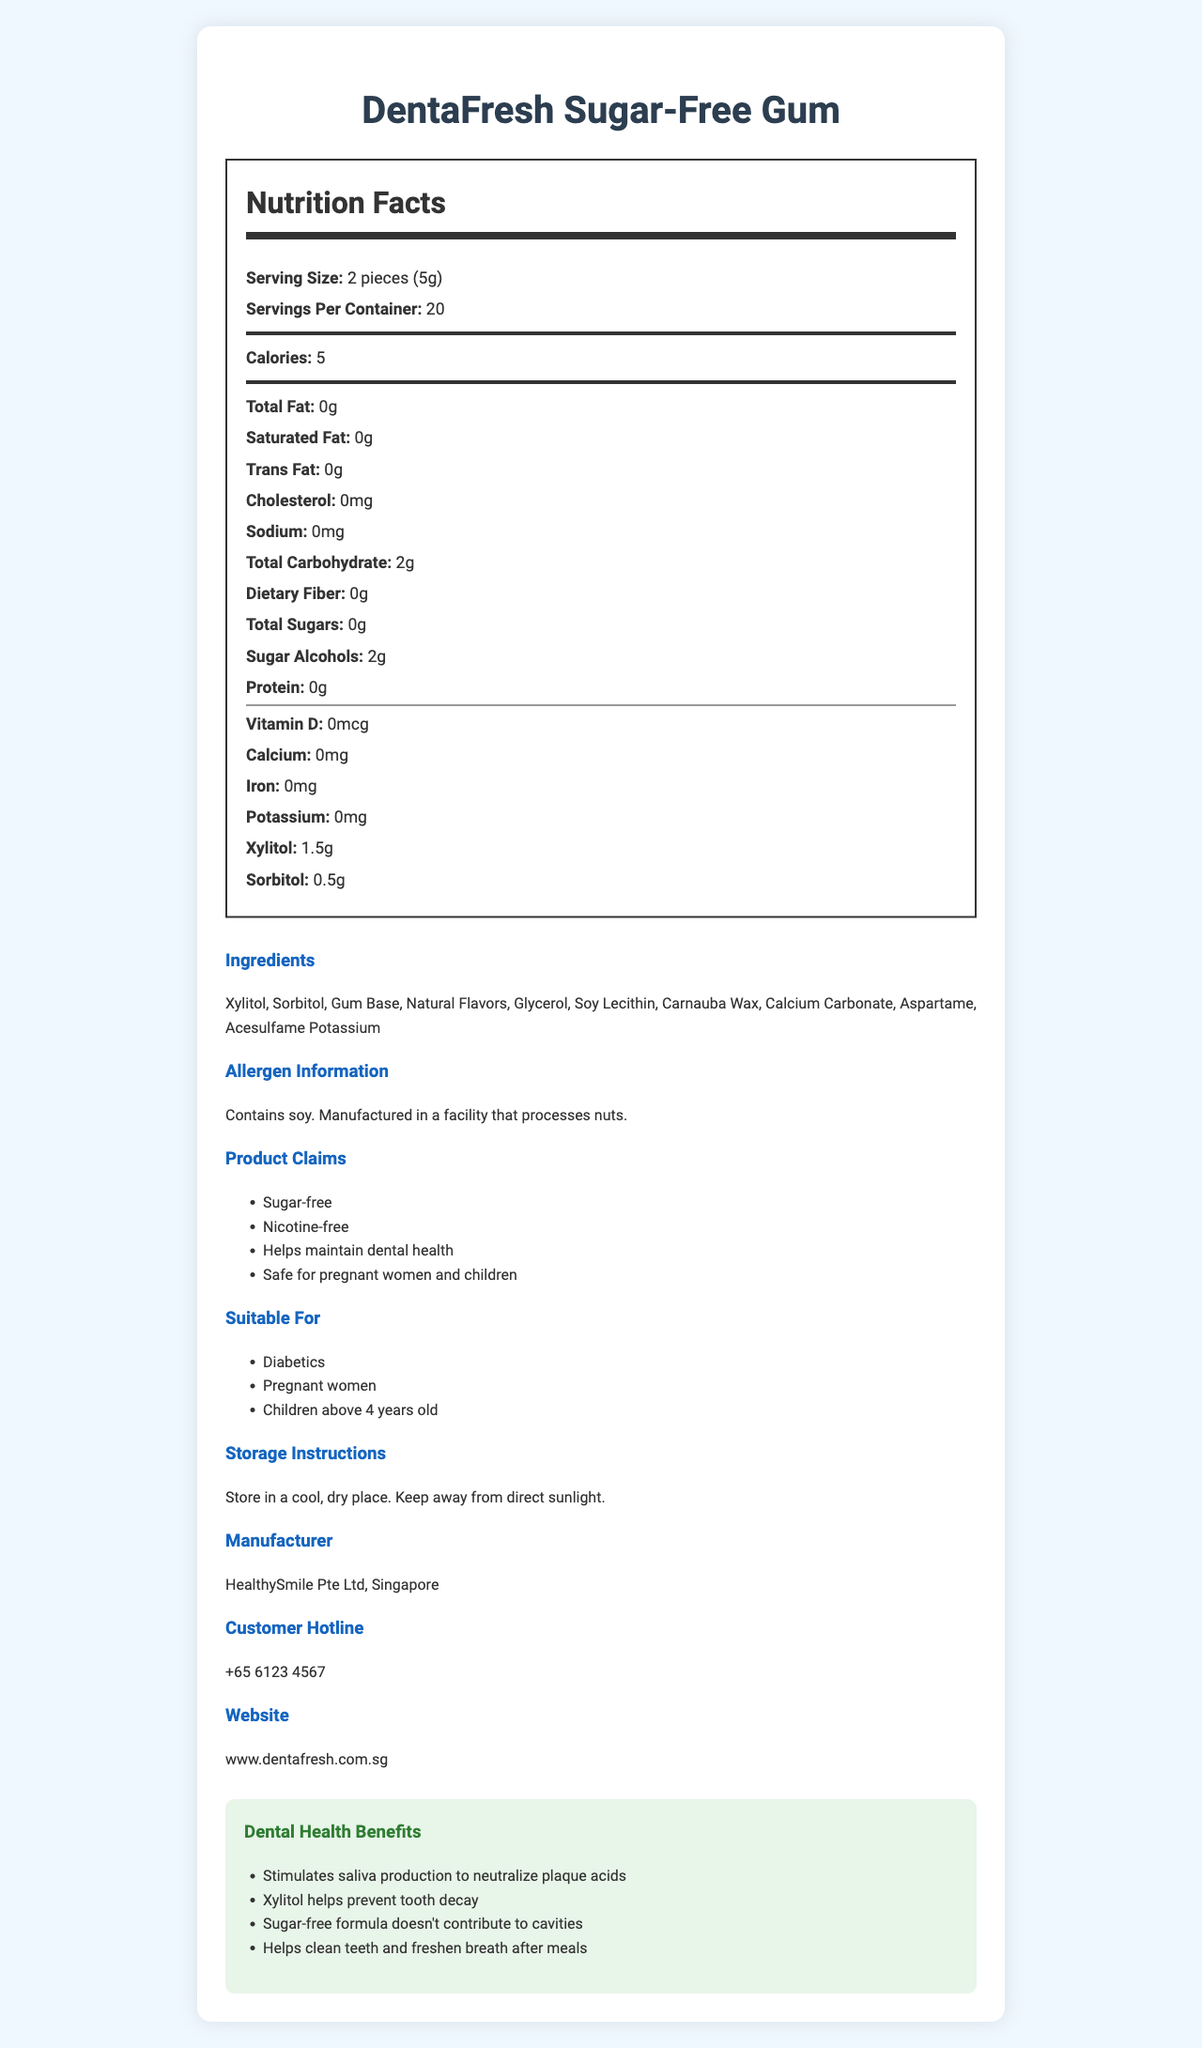what is the serving size for DentaFresh Sugar-Free Gum? The serving size is clearly mentioned as "2 pieces (5g)" in the Nutrition Facts section.
Answer: 2 pieces (5g) how many calories are there per serving? The document states that there are 5 calories per serving in the Nutrition Facts section.
Answer: 5 what ingredient helps prevent tooth decay? The Dental Health Benefits section mentions that Xylitol helps prevent tooth decay.
Answer: Xylitol how many servings are there per container? The Nutrition Facts section lists "20" as the servings per container.
Answer: 20 what is the total carbohydrate content per serving? The total carbohydrate content per serving is specified as "2g" in the Nutrition Facts section.
Answer: 2g which of the following is not an ingredient in DentaFresh Sugar-Free Gum? A. Aspartame B. Malitol C. Sorbitol D. Xylitol Malitol is not listed among the ingredients while Aspartame, Sorbitol, and Xylitol are.
Answer: B what makes this gum suitable for diabetics? A. Low sugar B. Contains xylitol C. Sugar-free formula D. High fiber content The Product Claims section highlights that the gum is "Sugar-free."
Answer: C is DentaFresh Sugar-Free Gum approved by the Singapore HSA for dental health claims? The document clearly states that it is "HSA-approved for dental health claims."
Answer: Yes how can this gum benefit dental health? The Dental Health Benefits section lists these multiple benefits.
Answer: It stimulates saliva production, helps prevent tooth decay, doesn't contribute to cavities, and helps clean teeth and freshen breath after meals. what is the main idea of this document? The document includes sections on nutrition facts, dental benefits, ingredients, and usage instructions, indicating it’s geared towards providing detailed product information.
Answer: The document provides comprehensive information about DentaFresh Sugar-Free Gum, including its nutritional facts, dental health benefits, ingredients, and suitability for various groups. how much iron is in each serving of the gum? The Nutrition Facts section shows that the iron content per serving is "0mg."
Answer: 0mg can this gum be stored in direct sunlight? The Storage Instructions section advises to "keep away from direct sunlight."
Answer: No what is the total amount of xylitol per serving? The Nutrition Facts section lists 1.5g of xylitol per serving.
Answer: 1.5g where is the gum manufactured? The Manufacturer section states that the gum is made by "HealthySmile Pte Ltd, Singapore."
Answer: Singapore is there a warning related to allergies? The Allergen Information section indicates that the product "contains soy" and is "manufactured in a facility that processes nuts."
Answer: Yes what percentage of daily potassium intake does this gum provide? The document does not include any information or context for daily potassium intake percentages.
Answer: Not enough information 